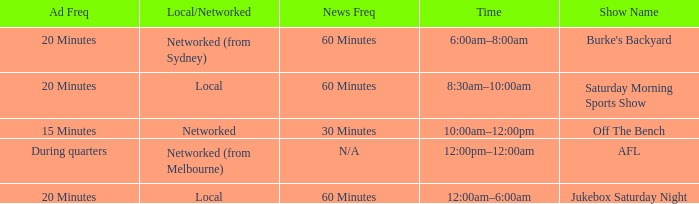What is the local/network with an Ad frequency of 15 minutes? Networked. 